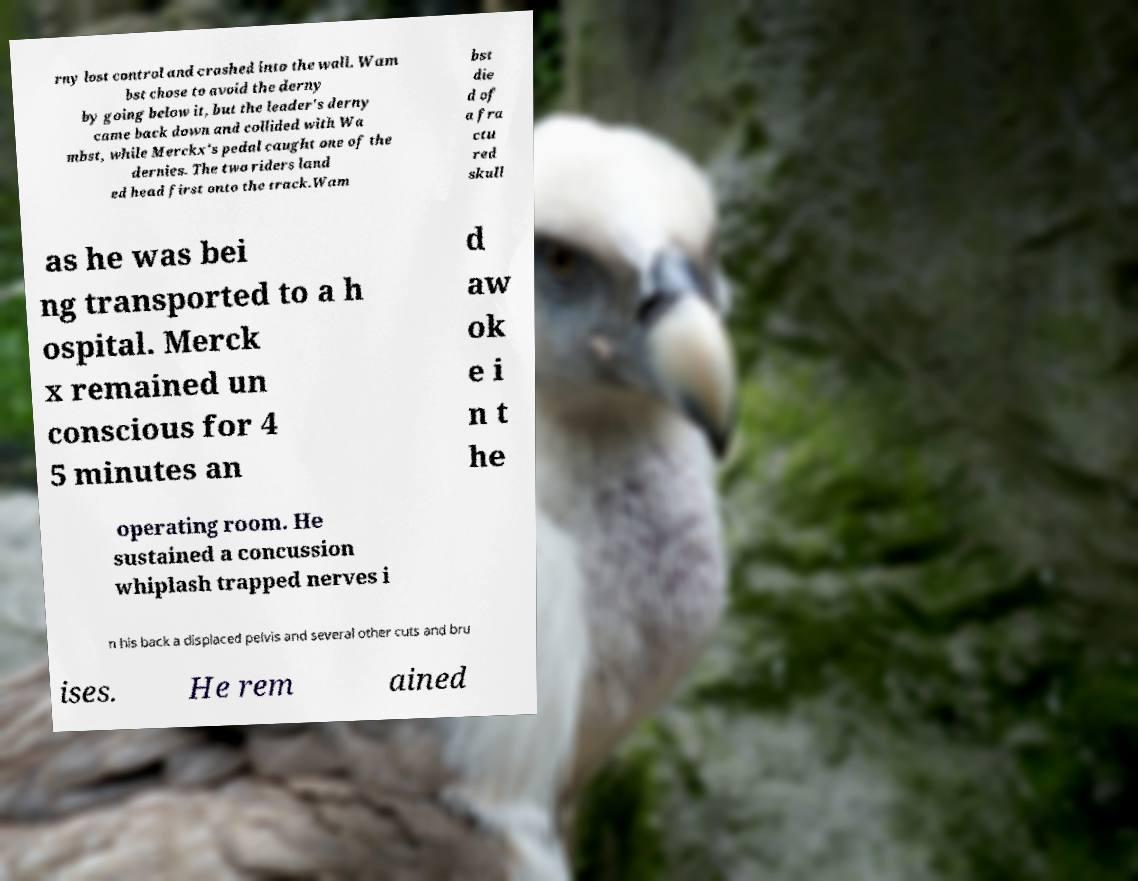Please read and relay the text visible in this image. What does it say? rny lost control and crashed into the wall. Wam bst chose to avoid the derny by going below it, but the leader's derny came back down and collided with Wa mbst, while Merckx's pedal caught one of the dernies. The two riders land ed head first onto the track.Wam bst die d of a fra ctu red skull as he was bei ng transported to a h ospital. Merck x remained un conscious for 4 5 minutes an d aw ok e i n t he operating room. He sustained a concussion whiplash trapped nerves i n his back a displaced pelvis and several other cuts and bru ises. He rem ained 